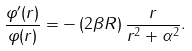<formula> <loc_0><loc_0><loc_500><loc_500>\frac { \varphi ^ { \prime } ( r ) } { \varphi ( r ) } = - \left ( 2 \beta R \right ) \frac { r } { r ^ { 2 } + \alpha ^ { 2 } } .</formula> 